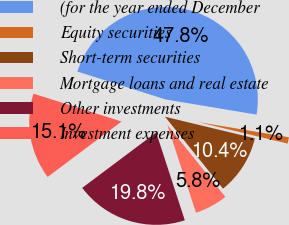Convert chart to OTSL. <chart><loc_0><loc_0><loc_500><loc_500><pie_chart><fcel>(for the year ended December<fcel>Equity securities<fcel>Short-term securities<fcel>Mortgage loans and real estate<fcel>Other investments<fcel>Investment expenses<nl><fcel>47.76%<fcel>1.12%<fcel>10.45%<fcel>5.78%<fcel>19.78%<fcel>15.11%<nl></chart> 